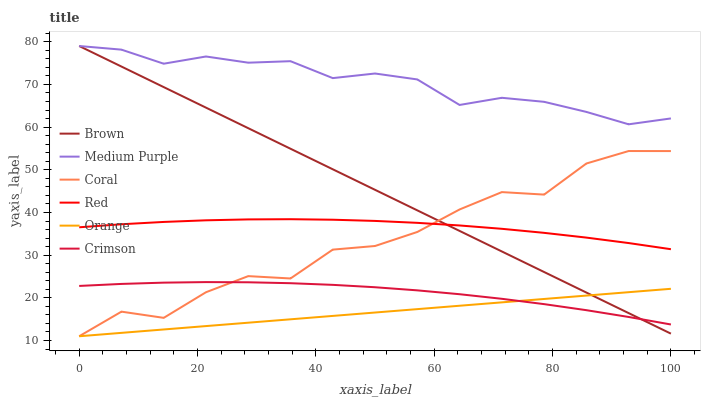Does Orange have the minimum area under the curve?
Answer yes or no. Yes. Does Medium Purple have the maximum area under the curve?
Answer yes or no. Yes. Does Coral have the minimum area under the curve?
Answer yes or no. No. Does Coral have the maximum area under the curve?
Answer yes or no. No. Is Orange the smoothest?
Answer yes or no. Yes. Is Coral the roughest?
Answer yes or no. Yes. Is Medium Purple the smoothest?
Answer yes or no. No. Is Medium Purple the roughest?
Answer yes or no. No. Does Coral have the lowest value?
Answer yes or no. Yes. Does Medium Purple have the lowest value?
Answer yes or no. No. Does Medium Purple have the highest value?
Answer yes or no. Yes. Does Coral have the highest value?
Answer yes or no. No. Is Red less than Medium Purple?
Answer yes or no. Yes. Is Medium Purple greater than Coral?
Answer yes or no. Yes. Does Orange intersect Crimson?
Answer yes or no. Yes. Is Orange less than Crimson?
Answer yes or no. No. Is Orange greater than Crimson?
Answer yes or no. No. Does Red intersect Medium Purple?
Answer yes or no. No. 